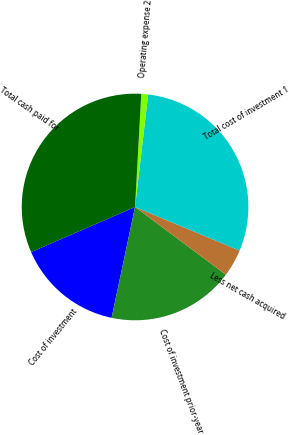<chart> <loc_0><loc_0><loc_500><loc_500><pie_chart><fcel>Cost of investment<fcel>Cost of investment prior-year<fcel>Less net cash acquired<fcel>Total cost of investment 1<fcel>Operating expense 2<fcel>Total cash paid for<nl><fcel>15.17%<fcel>18.12%<fcel>3.91%<fcel>29.44%<fcel>0.97%<fcel>32.39%<nl></chart> 